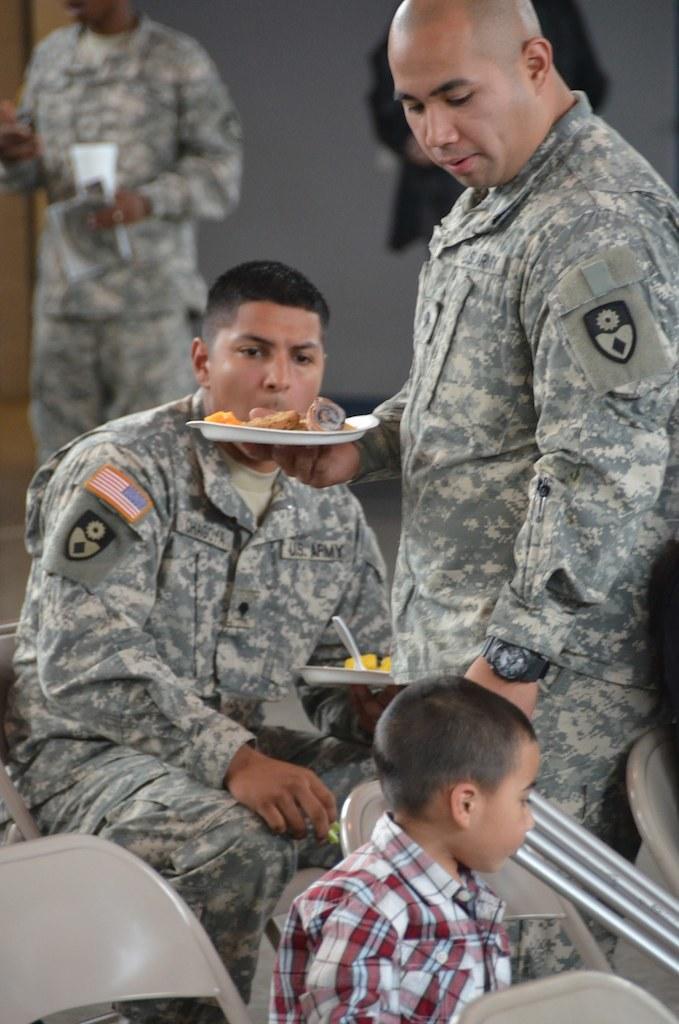Describe this image in one or two sentences. In this image we can see two army people, one is standing and the other one is sitting. They are holding plates in their hand. In front of them chairs are there, on chair one boy is sitting. Behind one more army man is standing 